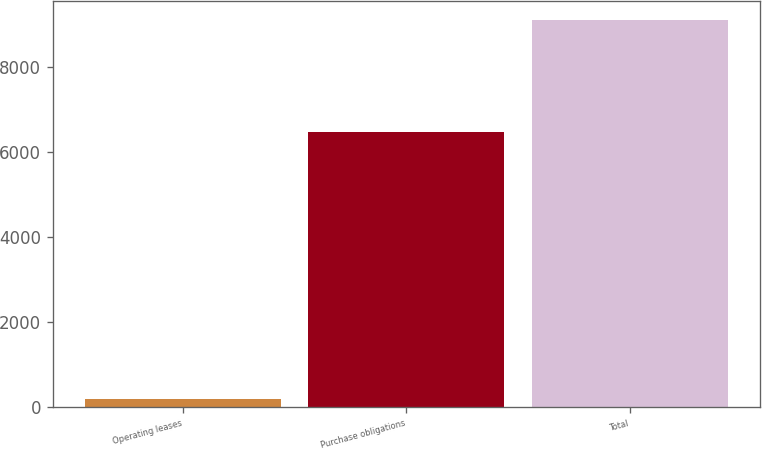<chart> <loc_0><loc_0><loc_500><loc_500><bar_chart><fcel>Operating leases<fcel>Purchase obligations<fcel>Total<nl><fcel>192<fcel>6468<fcel>9090<nl></chart> 